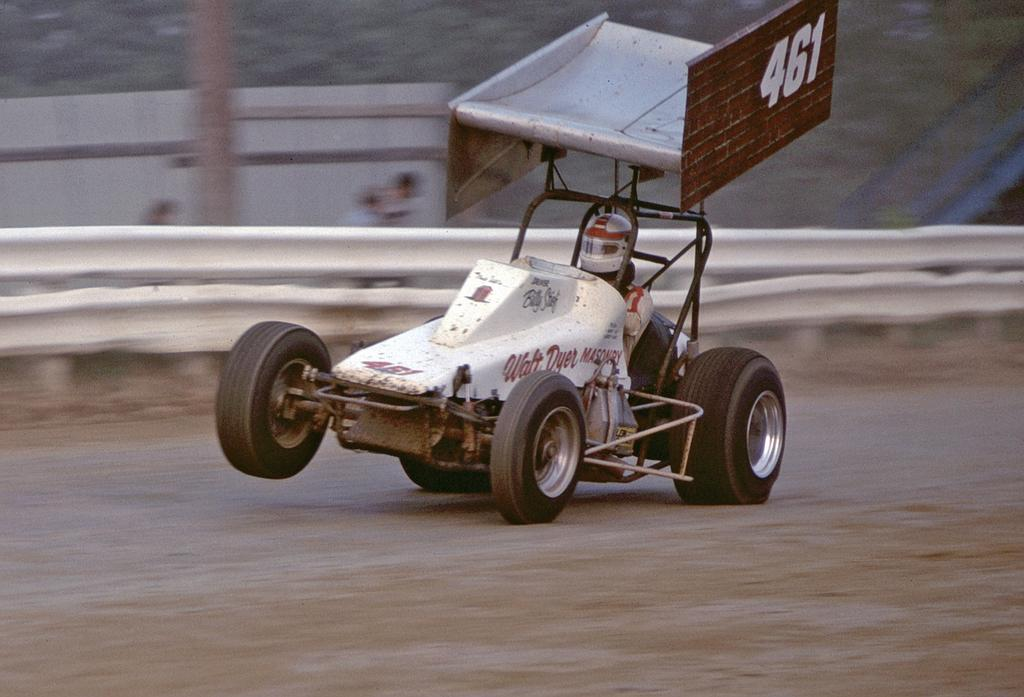What is the main action being performed by the person in the image? There is a person driving a vehicle in the image. What can be seen on the vehicle besides the person driving? There is text on the vehicle. What is located behind the vehicle in the image? There is a barrier behind the vehicle. How would you describe the background of the image? The background of the image is blurred. Can you see a flock of birds flying in the image? There is no flock of birds flying in the image. What type of toys are present in the image? There are no toys present in the image. 